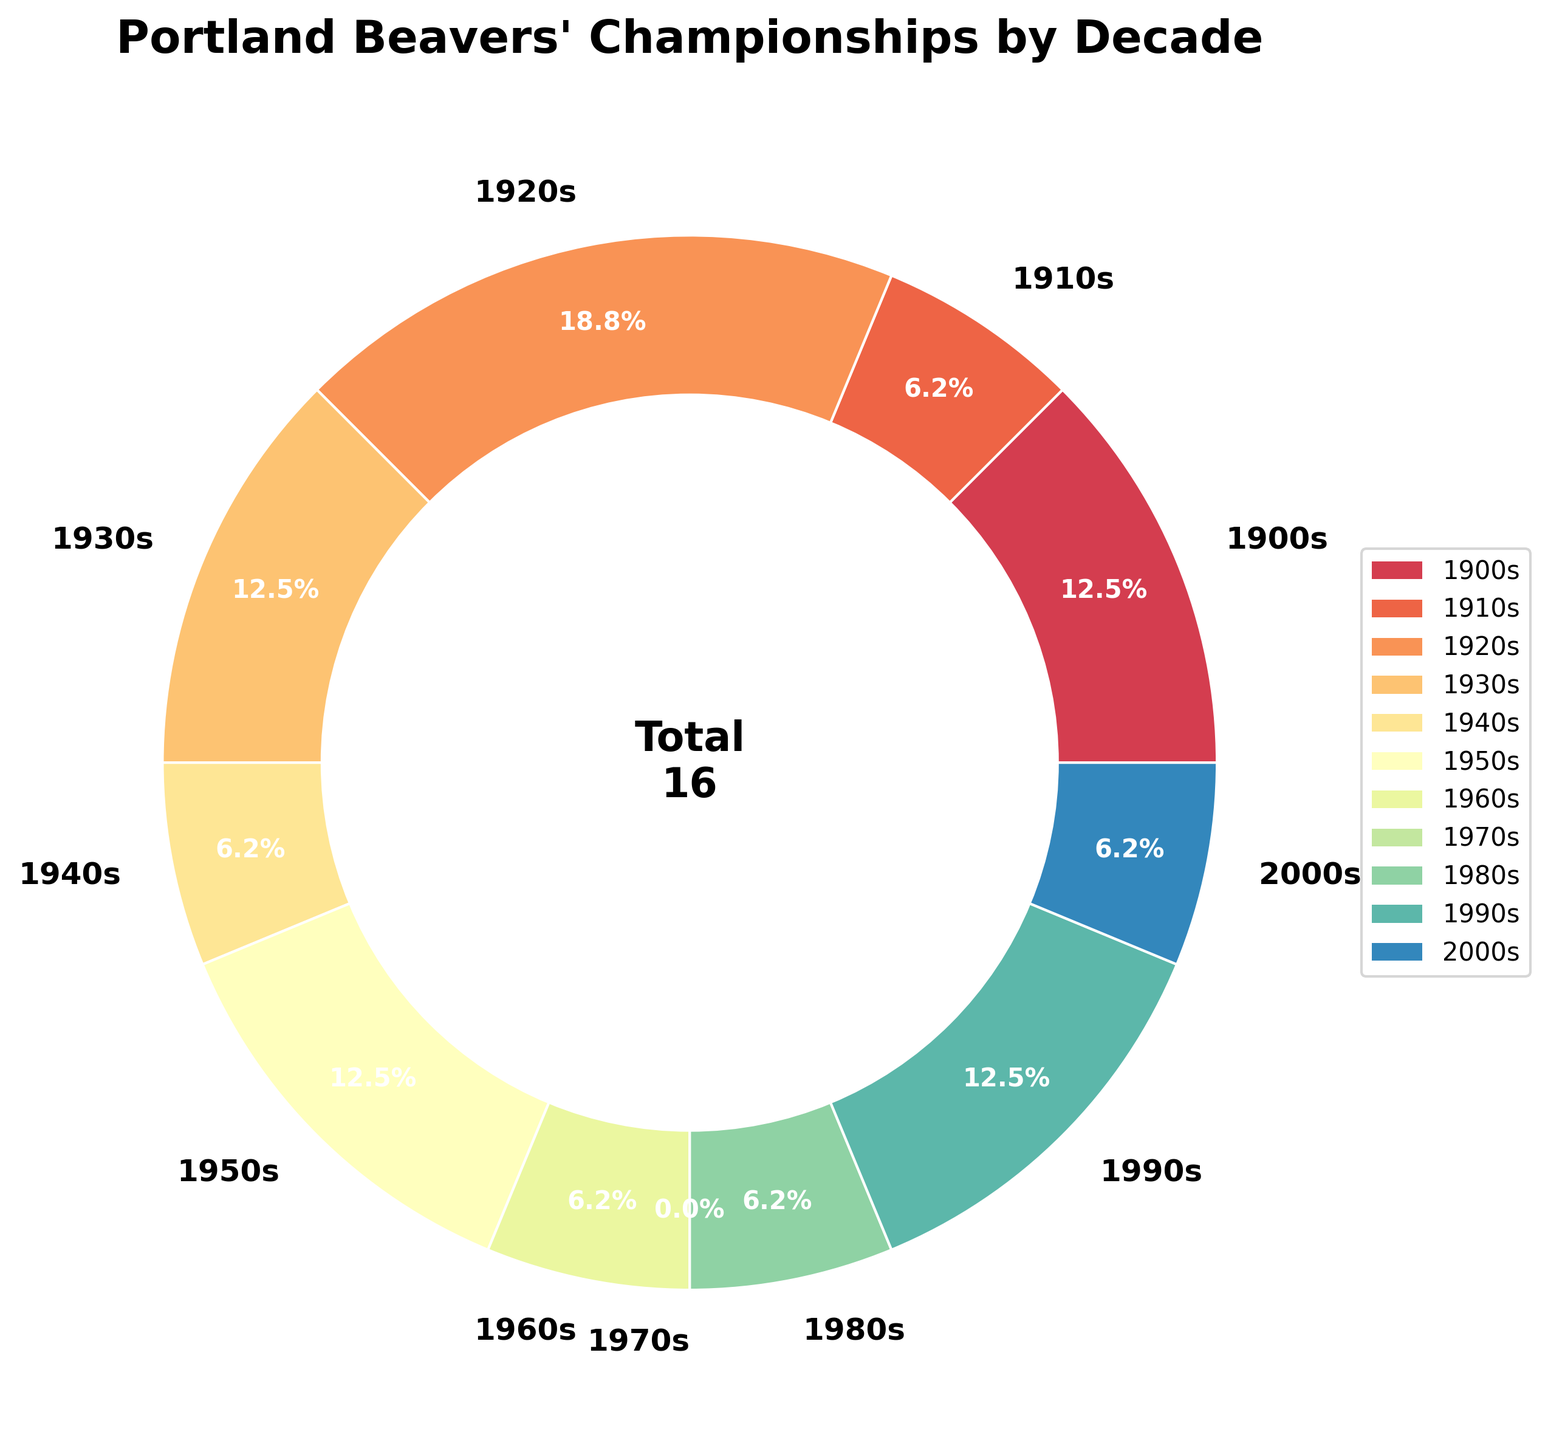Which decade had the highest number of championships? The wedge representing the 1920s is the largest, and it holds 3 championships.
Answer: 1920s How many championships did the Portland Beavers win in the 1940s and 1950s combined? The figure shows 1 championship in the 1940s and 2 in the 1950s. Adding these gives 1 + 2.
Answer: 3 Which decades have the same number of championships? The 1900s, 1930s, 1950s, and 1990s all have 2 championships. The 1910s, 1960s, 1980s, and 2000s each have 1 championship. Therefore, these sets of decades have equal championships.
Answer: 1900s, 1930s, 1950s, 1990s and 1910s, 1960s, 1980s, 2000s What is the total number of championships won by the Portland Beavers? The total number of championships is displayed in the center of the pie chart. It sums up to 16.
Answer: 16 Which decade has the smallest percentage of total championships and what is that percentage? The 1970s has the smallest percentage of the pie chart since it has 0 championships. Therefore, its percentage is 0%.
Answer: 0%, 1970s What percentage of the total championships were won in the decades before 1950? Add the championships from 1900s, 1910s, 1920s, 1930s, and 1940s: 2 + 1 + 3 + 2 + 1 = 9. Then 9/16 * 100 to get the percentage.
Answer: 56.3% What can you say about the trend in the number of championships over the decades? Looking at the chart, it is evident that the number of championships fluctuates across the decades without a clear increasing or decreasing trend.
Answer: Fluctuating trend How does the percentage of championships in the 2000s compare to that in the 1960s? Both the 2000s and 1960s wedges indicate 1 championship. Since the total championships are the same, their percentages are equal.
Answer: Equal How many more championships did the Beavers win in the 1920s compared to the 1940s? The 1920s had 3 championships, while the 1940s had 1 championship. The difference is 3 - 1.
Answer: 2 more What color represents the decade with the least number of championships? The decade with the least number is the 1970s (0 championships). The color of this section would be identified in the pie chart's color scheme.
Answer: Color representing 1970s 